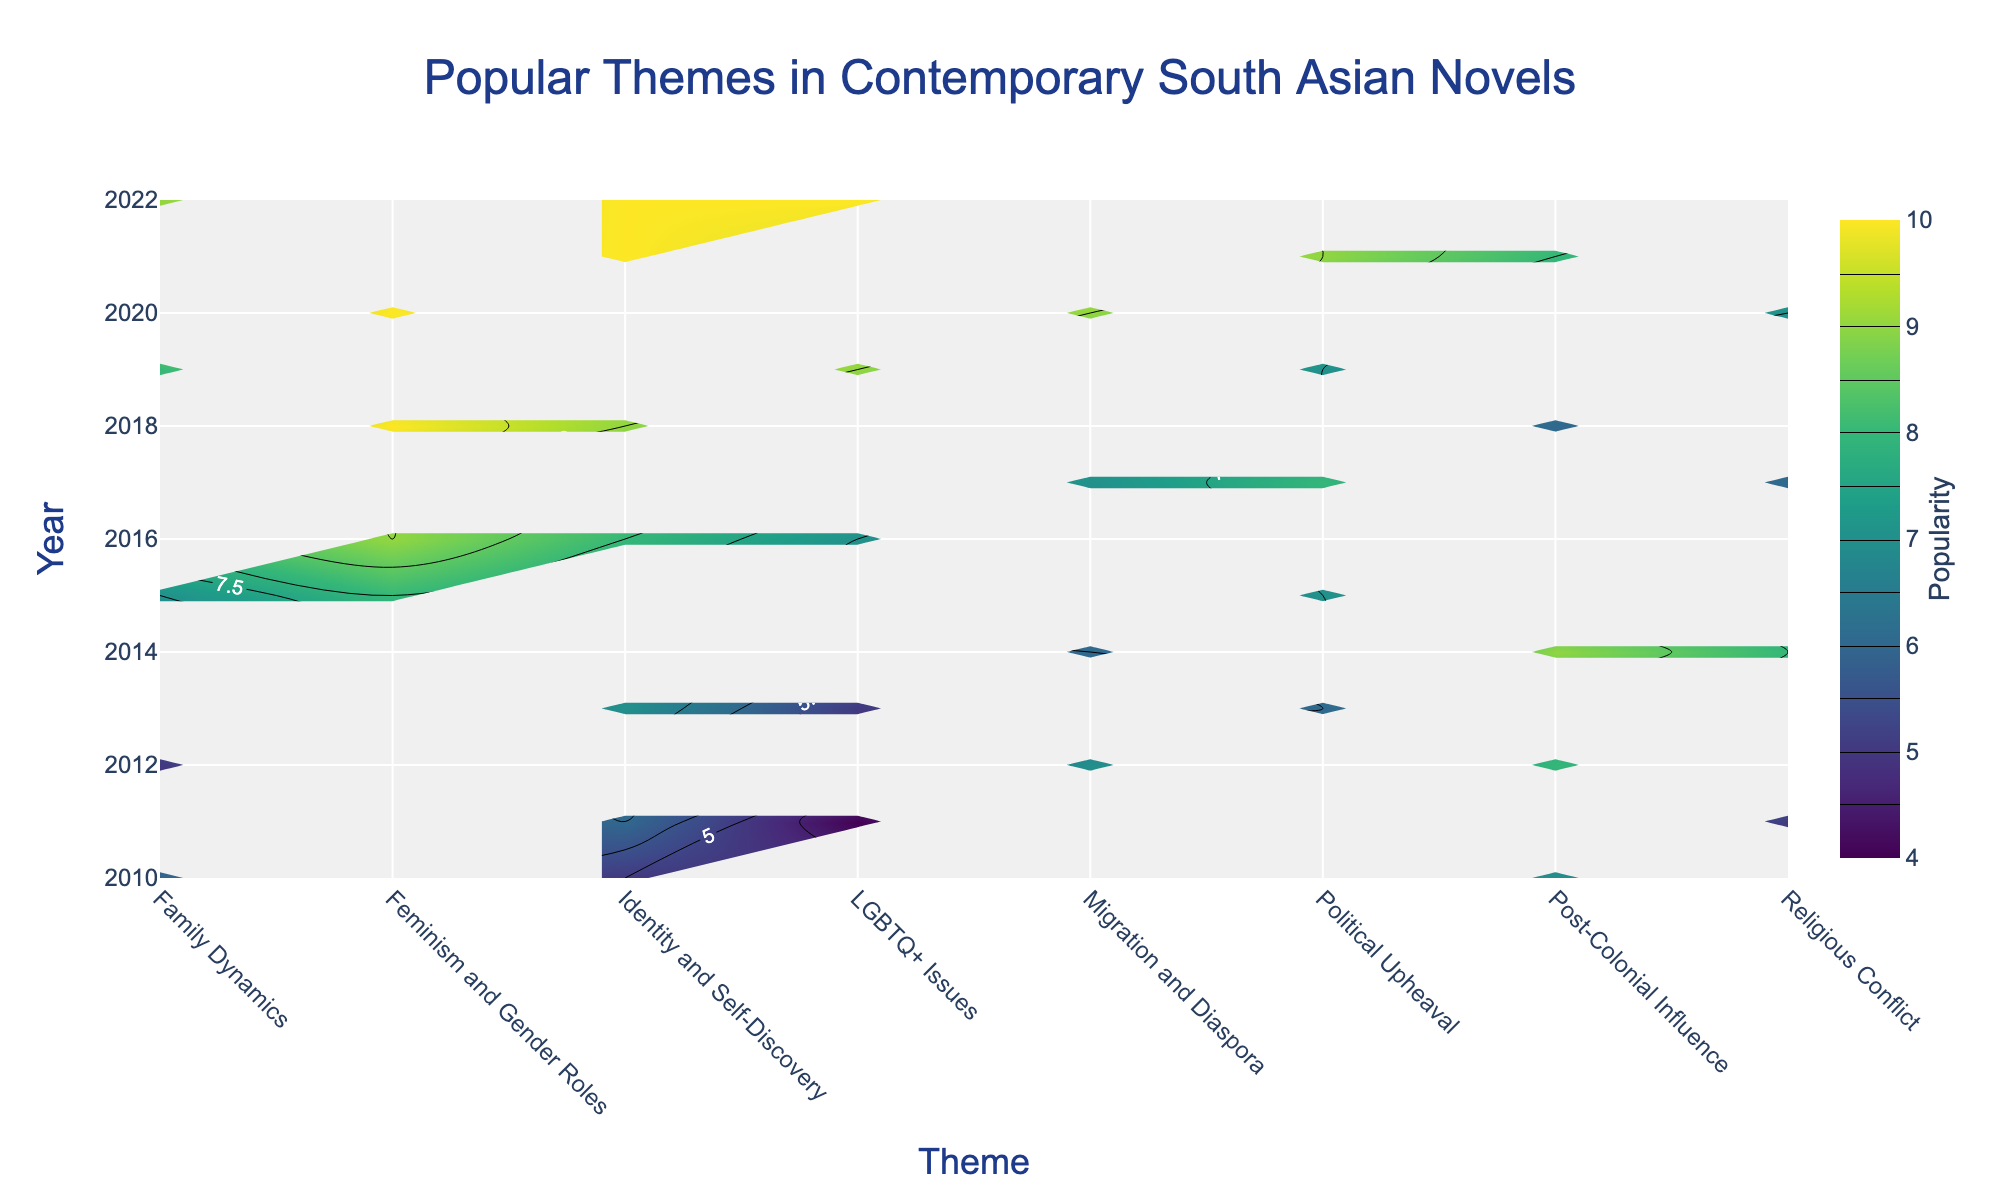Who wrote the code to generate this plot? The title of the plot states "Popular Themes in Contemporary South Asian Novels," indicating it was generated based on data provided on popular themes, but there is no reference to the author's identity in the figure.
Answer: The author isn't specified in the figure What is the most popular theme in 2022? Looking at the year 2022 on the y-axis and identifying the theme with the highest popularity value using the color intensity and labels, we find "Identity and Self-Discovery" is the most popular theme with a popularity of 10.
Answer: Identity and Self-Discovery Which theme has consistently increased in popularity from 2015 to 2022? Reviewing the contour plot from 2015 to 2022, "LGBTQ+ Issues" shows an increasing trend in popularity, starting from 5 in 2013 to 10 in 2022.
Answer: LGBTQ+ Issues How does the popularity of "Post-Colonial Influence" in 2010 compare to that in 2021? By comparing the contour labels for "Post-Colonial Influence" in 2010 and 2021, we see that the popularity value increases from 7 in 2010 to 8 in 2021.
Answer: Increased by 1 What is the average popularity of "Political Upheaval" across all years? Summing the popularity values for "Political Upheaval" across the years (2013:6, 2015:7, 2017:8, 2019:7, 2021:9) gives a total of 37. Dividing by the number of years (5) results in an average of 7.4.
Answer: 7.4 Which themes saw a peak in popularity in 2020? From the contour labels for the year 2020, both "Feminism and Gender Roles" and "Migration and Diaspora" have the highest popularity value of 10.
Answer: Feminism and Gender Roles, Migration and Diaspora What is the sum of the popularity values of "Family Dynamics" in 2010 and 2022? The popularity value of "Family Dynamics" in 2010 is 6 and in 2022 is 9. Summing these values gives 6 + 9 = 15.
Answer: 15 Which theme showed a decline in popularity from 2012 to 2018? Comparing the popularity values over these years, "Post-Colonial Influence" declines from 8 in 2012 to 6 in 2018.
Answer: Post-Colonial Influence What is the highest popularity value observed in the plot, and which theme does it correspond to? The maximum contour label observed is 10, which corresponds to several themes such as "Feminism and Gender Roles" and "Identity and Self-Discovery."
Answer: 10, Feminism and Gender Roles, Identity and Self-Discovery How many themes reached a popularity value of 9 in the year 2016? Observing the contour plot for 2016, both "Identity and Self-Discovery" and "Feminism and Gender Roles" reach a popularity value of 9.
Answer: 2 